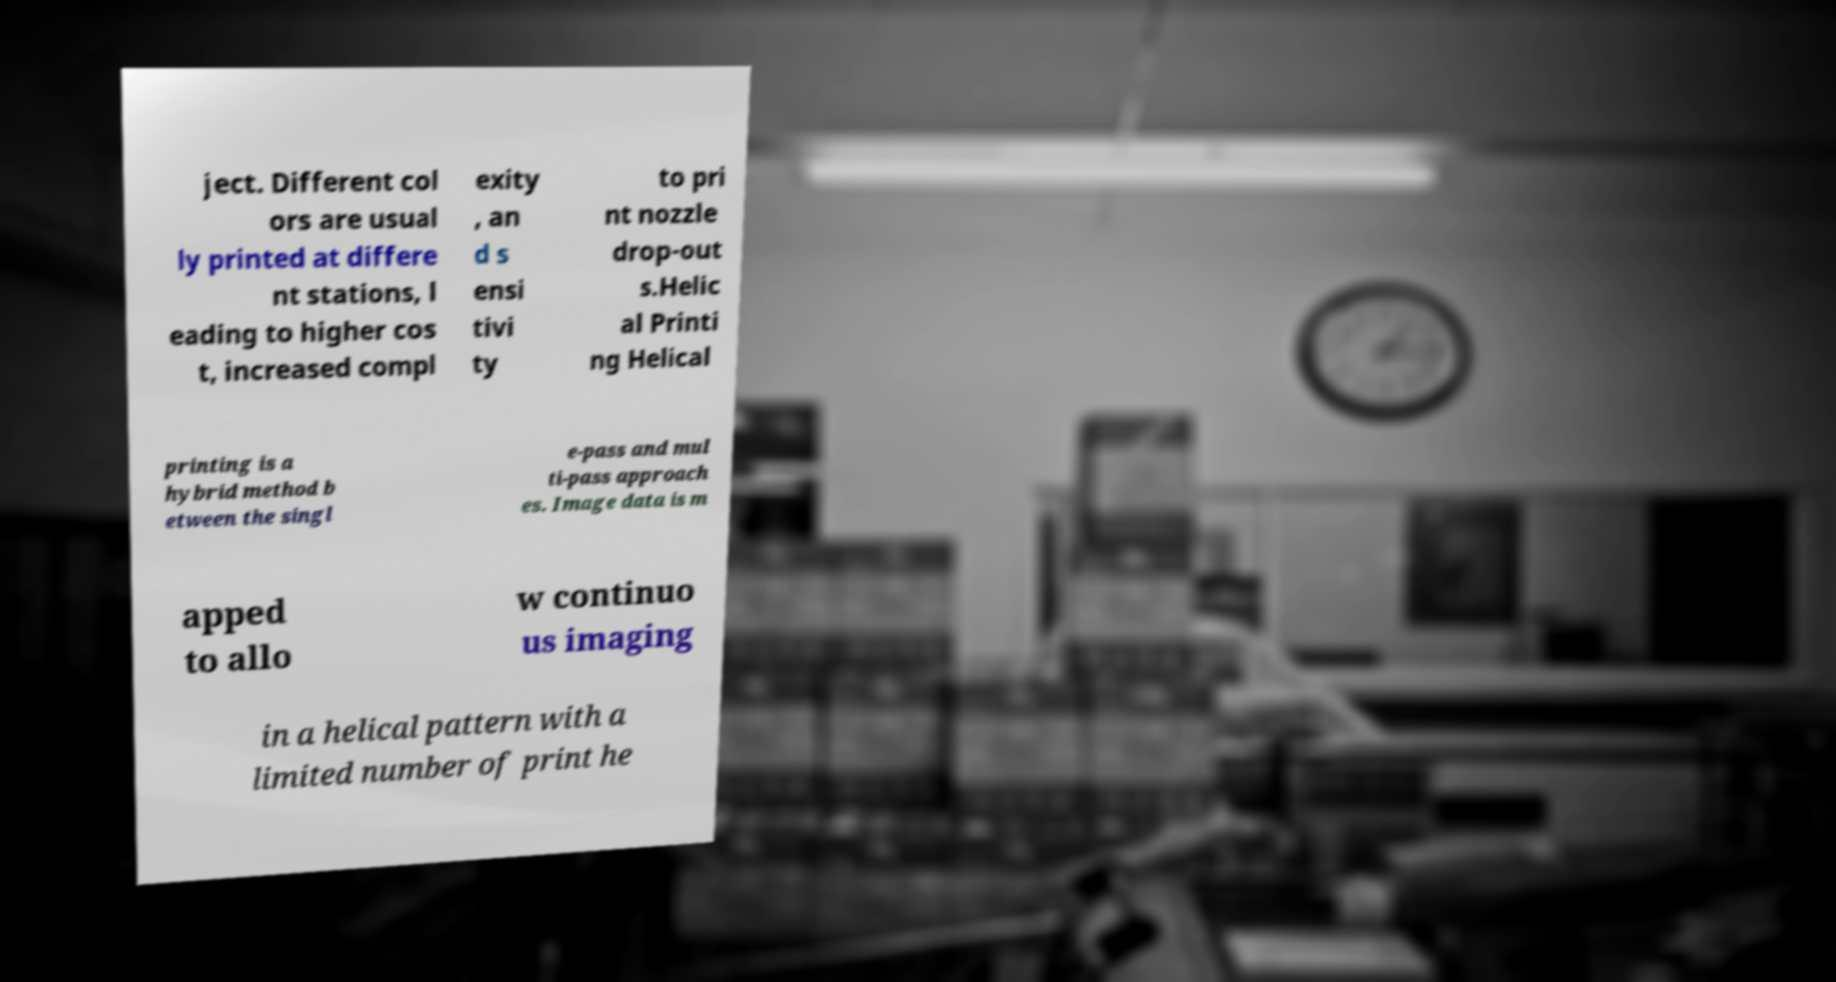Please read and relay the text visible in this image. What does it say? ject. Different col ors are usual ly printed at differe nt stations, l eading to higher cos t, increased compl exity , an d s ensi tivi ty to pri nt nozzle drop-out s.Helic al Printi ng Helical printing is a hybrid method b etween the singl e-pass and mul ti-pass approach es. Image data is m apped to allo w continuo us imaging in a helical pattern with a limited number of print he 